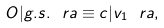Convert formula to latex. <formula><loc_0><loc_0><loc_500><loc_500>O | g . s . \ r a \equiv c | v _ { 1 } \ r a ,</formula> 